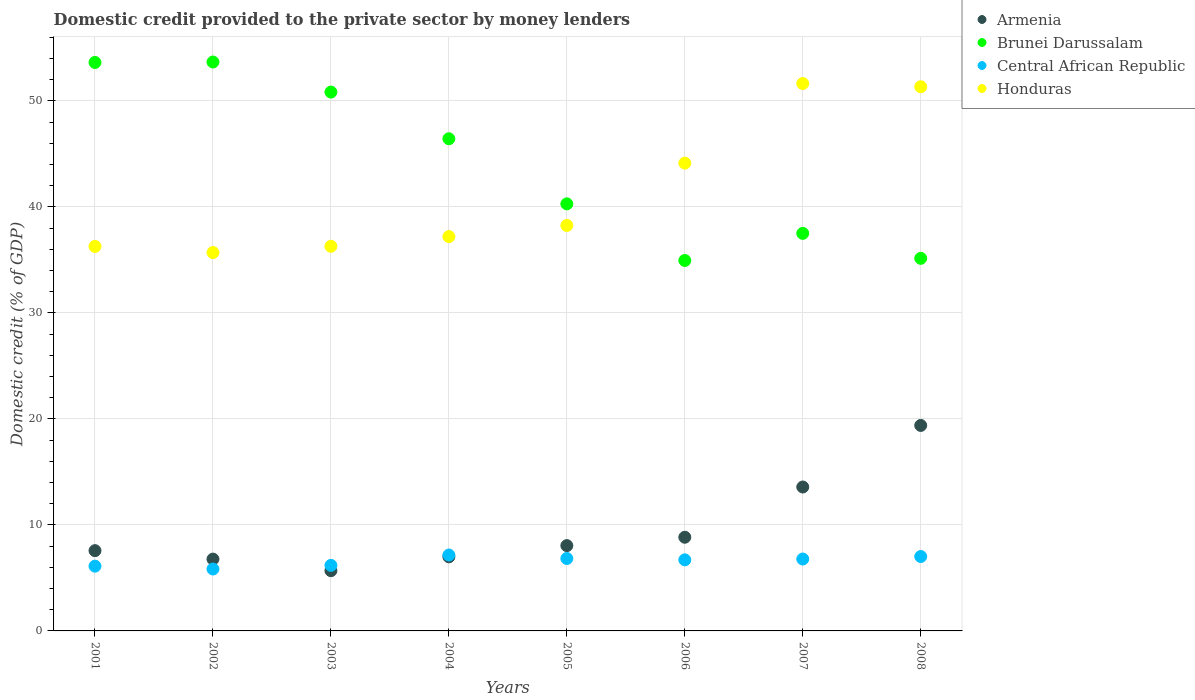What is the domestic credit provided to the private sector by money lenders in Honduras in 2004?
Your answer should be compact. 37.2. Across all years, what is the maximum domestic credit provided to the private sector by money lenders in Brunei Darussalam?
Your answer should be very brief. 53.68. Across all years, what is the minimum domestic credit provided to the private sector by money lenders in Brunei Darussalam?
Provide a short and direct response. 34.95. In which year was the domestic credit provided to the private sector by money lenders in Brunei Darussalam maximum?
Offer a terse response. 2002. In which year was the domestic credit provided to the private sector by money lenders in Armenia minimum?
Your response must be concise. 2003. What is the total domestic credit provided to the private sector by money lenders in Central African Republic in the graph?
Offer a very short reply. 52.64. What is the difference between the domestic credit provided to the private sector by money lenders in Armenia in 2004 and that in 2008?
Offer a terse response. -12.4. What is the difference between the domestic credit provided to the private sector by money lenders in Honduras in 2004 and the domestic credit provided to the private sector by money lenders in Brunei Darussalam in 2002?
Offer a terse response. -16.47. What is the average domestic credit provided to the private sector by money lenders in Central African Republic per year?
Provide a short and direct response. 6.58. In the year 2007, what is the difference between the domestic credit provided to the private sector by money lenders in Central African Republic and domestic credit provided to the private sector by money lenders in Armenia?
Make the answer very short. -6.79. What is the ratio of the domestic credit provided to the private sector by money lenders in Brunei Darussalam in 2001 to that in 2005?
Ensure brevity in your answer.  1.33. Is the difference between the domestic credit provided to the private sector by money lenders in Central African Republic in 2001 and 2005 greater than the difference between the domestic credit provided to the private sector by money lenders in Armenia in 2001 and 2005?
Your answer should be very brief. No. What is the difference between the highest and the second highest domestic credit provided to the private sector by money lenders in Brunei Darussalam?
Offer a very short reply. 0.04. What is the difference between the highest and the lowest domestic credit provided to the private sector by money lenders in Central African Republic?
Your answer should be compact. 1.32. In how many years, is the domestic credit provided to the private sector by money lenders in Armenia greater than the average domestic credit provided to the private sector by money lenders in Armenia taken over all years?
Ensure brevity in your answer.  2. Is it the case that in every year, the sum of the domestic credit provided to the private sector by money lenders in Honduras and domestic credit provided to the private sector by money lenders in Brunei Darussalam  is greater than the domestic credit provided to the private sector by money lenders in Armenia?
Your answer should be very brief. Yes. Is the domestic credit provided to the private sector by money lenders in Armenia strictly greater than the domestic credit provided to the private sector by money lenders in Central African Republic over the years?
Offer a terse response. No. What is the difference between two consecutive major ticks on the Y-axis?
Offer a very short reply. 10. Where does the legend appear in the graph?
Keep it short and to the point. Top right. How are the legend labels stacked?
Provide a succinct answer. Vertical. What is the title of the graph?
Make the answer very short. Domestic credit provided to the private sector by money lenders. What is the label or title of the Y-axis?
Give a very brief answer. Domestic credit (% of GDP). What is the Domestic credit (% of GDP) in Armenia in 2001?
Provide a succinct answer. 7.57. What is the Domestic credit (% of GDP) in Brunei Darussalam in 2001?
Offer a very short reply. 53.63. What is the Domestic credit (% of GDP) of Central African Republic in 2001?
Give a very brief answer. 6.11. What is the Domestic credit (% of GDP) in Honduras in 2001?
Provide a short and direct response. 36.28. What is the Domestic credit (% of GDP) in Armenia in 2002?
Your answer should be very brief. 6.78. What is the Domestic credit (% of GDP) in Brunei Darussalam in 2002?
Provide a short and direct response. 53.68. What is the Domestic credit (% of GDP) of Central African Republic in 2002?
Keep it short and to the point. 5.84. What is the Domestic credit (% of GDP) of Honduras in 2002?
Keep it short and to the point. 35.7. What is the Domestic credit (% of GDP) of Armenia in 2003?
Make the answer very short. 5.68. What is the Domestic credit (% of GDP) in Brunei Darussalam in 2003?
Provide a short and direct response. 50.84. What is the Domestic credit (% of GDP) in Central African Republic in 2003?
Make the answer very short. 6.18. What is the Domestic credit (% of GDP) in Honduras in 2003?
Give a very brief answer. 36.29. What is the Domestic credit (% of GDP) of Armenia in 2004?
Provide a short and direct response. 6.99. What is the Domestic credit (% of GDP) in Brunei Darussalam in 2004?
Give a very brief answer. 46.44. What is the Domestic credit (% of GDP) in Central African Republic in 2004?
Your answer should be compact. 7.16. What is the Domestic credit (% of GDP) of Honduras in 2004?
Your answer should be compact. 37.2. What is the Domestic credit (% of GDP) in Armenia in 2005?
Your answer should be very brief. 8.05. What is the Domestic credit (% of GDP) of Brunei Darussalam in 2005?
Provide a short and direct response. 40.29. What is the Domestic credit (% of GDP) in Central African Republic in 2005?
Keep it short and to the point. 6.83. What is the Domestic credit (% of GDP) in Honduras in 2005?
Make the answer very short. 38.26. What is the Domestic credit (% of GDP) in Armenia in 2006?
Give a very brief answer. 8.84. What is the Domestic credit (% of GDP) in Brunei Darussalam in 2006?
Give a very brief answer. 34.95. What is the Domestic credit (% of GDP) of Central African Republic in 2006?
Provide a short and direct response. 6.71. What is the Domestic credit (% of GDP) of Honduras in 2006?
Provide a succinct answer. 44.14. What is the Domestic credit (% of GDP) in Armenia in 2007?
Your answer should be compact. 13.58. What is the Domestic credit (% of GDP) in Brunei Darussalam in 2007?
Your answer should be compact. 37.51. What is the Domestic credit (% of GDP) of Central African Republic in 2007?
Keep it short and to the point. 6.78. What is the Domestic credit (% of GDP) in Honduras in 2007?
Ensure brevity in your answer.  51.65. What is the Domestic credit (% of GDP) in Armenia in 2008?
Your response must be concise. 19.39. What is the Domestic credit (% of GDP) of Brunei Darussalam in 2008?
Offer a very short reply. 35.15. What is the Domestic credit (% of GDP) of Central African Republic in 2008?
Offer a terse response. 7.02. What is the Domestic credit (% of GDP) of Honduras in 2008?
Your answer should be very brief. 51.34. Across all years, what is the maximum Domestic credit (% of GDP) in Armenia?
Make the answer very short. 19.39. Across all years, what is the maximum Domestic credit (% of GDP) in Brunei Darussalam?
Make the answer very short. 53.68. Across all years, what is the maximum Domestic credit (% of GDP) in Central African Republic?
Your answer should be compact. 7.16. Across all years, what is the maximum Domestic credit (% of GDP) in Honduras?
Keep it short and to the point. 51.65. Across all years, what is the minimum Domestic credit (% of GDP) of Armenia?
Your answer should be compact. 5.68. Across all years, what is the minimum Domestic credit (% of GDP) of Brunei Darussalam?
Provide a succinct answer. 34.95. Across all years, what is the minimum Domestic credit (% of GDP) in Central African Republic?
Your answer should be compact. 5.84. Across all years, what is the minimum Domestic credit (% of GDP) in Honduras?
Provide a short and direct response. 35.7. What is the total Domestic credit (% of GDP) of Armenia in the graph?
Your answer should be compact. 76.87. What is the total Domestic credit (% of GDP) in Brunei Darussalam in the graph?
Offer a very short reply. 352.49. What is the total Domestic credit (% of GDP) in Central African Republic in the graph?
Provide a succinct answer. 52.64. What is the total Domestic credit (% of GDP) of Honduras in the graph?
Offer a terse response. 330.85. What is the difference between the Domestic credit (% of GDP) in Armenia in 2001 and that in 2002?
Offer a terse response. 0.8. What is the difference between the Domestic credit (% of GDP) in Brunei Darussalam in 2001 and that in 2002?
Keep it short and to the point. -0.04. What is the difference between the Domestic credit (% of GDP) in Central African Republic in 2001 and that in 2002?
Ensure brevity in your answer.  0.27. What is the difference between the Domestic credit (% of GDP) in Honduras in 2001 and that in 2002?
Ensure brevity in your answer.  0.58. What is the difference between the Domestic credit (% of GDP) of Armenia in 2001 and that in 2003?
Your answer should be very brief. 1.89. What is the difference between the Domestic credit (% of GDP) of Brunei Darussalam in 2001 and that in 2003?
Your response must be concise. 2.79. What is the difference between the Domestic credit (% of GDP) of Central African Republic in 2001 and that in 2003?
Provide a succinct answer. -0.07. What is the difference between the Domestic credit (% of GDP) of Honduras in 2001 and that in 2003?
Keep it short and to the point. -0.01. What is the difference between the Domestic credit (% of GDP) of Armenia in 2001 and that in 2004?
Your answer should be very brief. 0.58. What is the difference between the Domestic credit (% of GDP) of Brunei Darussalam in 2001 and that in 2004?
Make the answer very short. 7.2. What is the difference between the Domestic credit (% of GDP) in Central African Republic in 2001 and that in 2004?
Make the answer very short. -1.05. What is the difference between the Domestic credit (% of GDP) in Honduras in 2001 and that in 2004?
Provide a succinct answer. -0.93. What is the difference between the Domestic credit (% of GDP) in Armenia in 2001 and that in 2005?
Make the answer very short. -0.47. What is the difference between the Domestic credit (% of GDP) in Brunei Darussalam in 2001 and that in 2005?
Make the answer very short. 13.34. What is the difference between the Domestic credit (% of GDP) of Central African Republic in 2001 and that in 2005?
Give a very brief answer. -0.72. What is the difference between the Domestic credit (% of GDP) in Honduras in 2001 and that in 2005?
Offer a very short reply. -1.98. What is the difference between the Domestic credit (% of GDP) in Armenia in 2001 and that in 2006?
Give a very brief answer. -1.26. What is the difference between the Domestic credit (% of GDP) in Brunei Darussalam in 2001 and that in 2006?
Your answer should be compact. 18.68. What is the difference between the Domestic credit (% of GDP) of Central African Republic in 2001 and that in 2006?
Your answer should be compact. -0.6. What is the difference between the Domestic credit (% of GDP) of Honduras in 2001 and that in 2006?
Your answer should be very brief. -7.86. What is the difference between the Domestic credit (% of GDP) in Armenia in 2001 and that in 2007?
Ensure brevity in your answer.  -6. What is the difference between the Domestic credit (% of GDP) in Brunei Darussalam in 2001 and that in 2007?
Offer a terse response. 16.13. What is the difference between the Domestic credit (% of GDP) of Central African Republic in 2001 and that in 2007?
Give a very brief answer. -0.67. What is the difference between the Domestic credit (% of GDP) in Honduras in 2001 and that in 2007?
Your response must be concise. -15.37. What is the difference between the Domestic credit (% of GDP) in Armenia in 2001 and that in 2008?
Keep it short and to the point. -11.81. What is the difference between the Domestic credit (% of GDP) in Brunei Darussalam in 2001 and that in 2008?
Offer a very short reply. 18.48. What is the difference between the Domestic credit (% of GDP) of Central African Republic in 2001 and that in 2008?
Provide a short and direct response. -0.91. What is the difference between the Domestic credit (% of GDP) in Honduras in 2001 and that in 2008?
Provide a succinct answer. -15.07. What is the difference between the Domestic credit (% of GDP) of Armenia in 2002 and that in 2003?
Keep it short and to the point. 1.09. What is the difference between the Domestic credit (% of GDP) of Brunei Darussalam in 2002 and that in 2003?
Provide a succinct answer. 2.84. What is the difference between the Domestic credit (% of GDP) of Central African Republic in 2002 and that in 2003?
Your answer should be very brief. -0.34. What is the difference between the Domestic credit (% of GDP) in Honduras in 2002 and that in 2003?
Provide a succinct answer. -0.59. What is the difference between the Domestic credit (% of GDP) of Armenia in 2002 and that in 2004?
Your answer should be very brief. -0.21. What is the difference between the Domestic credit (% of GDP) in Brunei Darussalam in 2002 and that in 2004?
Your response must be concise. 7.24. What is the difference between the Domestic credit (% of GDP) of Central African Republic in 2002 and that in 2004?
Your response must be concise. -1.32. What is the difference between the Domestic credit (% of GDP) in Honduras in 2002 and that in 2004?
Your response must be concise. -1.51. What is the difference between the Domestic credit (% of GDP) in Armenia in 2002 and that in 2005?
Provide a short and direct response. -1.27. What is the difference between the Domestic credit (% of GDP) of Brunei Darussalam in 2002 and that in 2005?
Give a very brief answer. 13.38. What is the difference between the Domestic credit (% of GDP) in Central African Republic in 2002 and that in 2005?
Provide a succinct answer. -0.99. What is the difference between the Domestic credit (% of GDP) of Honduras in 2002 and that in 2005?
Give a very brief answer. -2.56. What is the difference between the Domestic credit (% of GDP) in Armenia in 2002 and that in 2006?
Your response must be concise. -2.06. What is the difference between the Domestic credit (% of GDP) of Brunei Darussalam in 2002 and that in 2006?
Ensure brevity in your answer.  18.73. What is the difference between the Domestic credit (% of GDP) in Central African Republic in 2002 and that in 2006?
Your response must be concise. -0.87. What is the difference between the Domestic credit (% of GDP) in Honduras in 2002 and that in 2006?
Your answer should be compact. -8.44. What is the difference between the Domestic credit (% of GDP) in Armenia in 2002 and that in 2007?
Your answer should be compact. -6.8. What is the difference between the Domestic credit (% of GDP) in Brunei Darussalam in 2002 and that in 2007?
Your answer should be very brief. 16.17. What is the difference between the Domestic credit (% of GDP) in Central African Republic in 2002 and that in 2007?
Offer a very short reply. -0.94. What is the difference between the Domestic credit (% of GDP) in Honduras in 2002 and that in 2007?
Keep it short and to the point. -15.95. What is the difference between the Domestic credit (% of GDP) in Armenia in 2002 and that in 2008?
Ensure brevity in your answer.  -12.61. What is the difference between the Domestic credit (% of GDP) in Brunei Darussalam in 2002 and that in 2008?
Your response must be concise. 18.52. What is the difference between the Domestic credit (% of GDP) of Central African Republic in 2002 and that in 2008?
Ensure brevity in your answer.  -1.18. What is the difference between the Domestic credit (% of GDP) of Honduras in 2002 and that in 2008?
Keep it short and to the point. -15.64. What is the difference between the Domestic credit (% of GDP) of Armenia in 2003 and that in 2004?
Offer a terse response. -1.31. What is the difference between the Domestic credit (% of GDP) of Brunei Darussalam in 2003 and that in 2004?
Give a very brief answer. 4.4. What is the difference between the Domestic credit (% of GDP) of Central African Republic in 2003 and that in 2004?
Offer a very short reply. -0.98. What is the difference between the Domestic credit (% of GDP) of Honduras in 2003 and that in 2004?
Ensure brevity in your answer.  -0.91. What is the difference between the Domestic credit (% of GDP) in Armenia in 2003 and that in 2005?
Make the answer very short. -2.37. What is the difference between the Domestic credit (% of GDP) in Brunei Darussalam in 2003 and that in 2005?
Provide a succinct answer. 10.55. What is the difference between the Domestic credit (% of GDP) in Central African Republic in 2003 and that in 2005?
Your answer should be very brief. -0.65. What is the difference between the Domestic credit (% of GDP) in Honduras in 2003 and that in 2005?
Provide a succinct answer. -1.97. What is the difference between the Domestic credit (% of GDP) in Armenia in 2003 and that in 2006?
Your response must be concise. -3.16. What is the difference between the Domestic credit (% of GDP) in Brunei Darussalam in 2003 and that in 2006?
Your answer should be compact. 15.89. What is the difference between the Domestic credit (% of GDP) in Central African Republic in 2003 and that in 2006?
Your answer should be very brief. -0.52. What is the difference between the Domestic credit (% of GDP) in Honduras in 2003 and that in 2006?
Your response must be concise. -7.85. What is the difference between the Domestic credit (% of GDP) in Armenia in 2003 and that in 2007?
Offer a very short reply. -7.9. What is the difference between the Domestic credit (% of GDP) of Brunei Darussalam in 2003 and that in 2007?
Offer a terse response. 13.33. What is the difference between the Domestic credit (% of GDP) of Central African Republic in 2003 and that in 2007?
Your answer should be compact. -0.6. What is the difference between the Domestic credit (% of GDP) of Honduras in 2003 and that in 2007?
Offer a very short reply. -15.36. What is the difference between the Domestic credit (% of GDP) of Armenia in 2003 and that in 2008?
Your answer should be compact. -13.7. What is the difference between the Domestic credit (% of GDP) in Brunei Darussalam in 2003 and that in 2008?
Provide a succinct answer. 15.69. What is the difference between the Domestic credit (% of GDP) of Central African Republic in 2003 and that in 2008?
Give a very brief answer. -0.84. What is the difference between the Domestic credit (% of GDP) of Honduras in 2003 and that in 2008?
Keep it short and to the point. -15.05. What is the difference between the Domestic credit (% of GDP) of Armenia in 2004 and that in 2005?
Your answer should be very brief. -1.06. What is the difference between the Domestic credit (% of GDP) in Brunei Darussalam in 2004 and that in 2005?
Offer a very short reply. 6.14. What is the difference between the Domestic credit (% of GDP) of Central African Republic in 2004 and that in 2005?
Offer a very short reply. 0.33. What is the difference between the Domestic credit (% of GDP) of Honduras in 2004 and that in 2005?
Ensure brevity in your answer.  -1.05. What is the difference between the Domestic credit (% of GDP) of Armenia in 2004 and that in 2006?
Ensure brevity in your answer.  -1.85. What is the difference between the Domestic credit (% of GDP) in Brunei Darussalam in 2004 and that in 2006?
Keep it short and to the point. 11.49. What is the difference between the Domestic credit (% of GDP) in Central African Republic in 2004 and that in 2006?
Your answer should be very brief. 0.45. What is the difference between the Domestic credit (% of GDP) in Honduras in 2004 and that in 2006?
Offer a very short reply. -6.93. What is the difference between the Domestic credit (% of GDP) of Armenia in 2004 and that in 2007?
Keep it short and to the point. -6.59. What is the difference between the Domestic credit (% of GDP) of Brunei Darussalam in 2004 and that in 2007?
Provide a succinct answer. 8.93. What is the difference between the Domestic credit (% of GDP) in Central African Republic in 2004 and that in 2007?
Your answer should be compact. 0.38. What is the difference between the Domestic credit (% of GDP) in Honduras in 2004 and that in 2007?
Your answer should be compact. -14.44. What is the difference between the Domestic credit (% of GDP) of Armenia in 2004 and that in 2008?
Your answer should be compact. -12.4. What is the difference between the Domestic credit (% of GDP) in Brunei Darussalam in 2004 and that in 2008?
Give a very brief answer. 11.28. What is the difference between the Domestic credit (% of GDP) in Central African Republic in 2004 and that in 2008?
Your answer should be very brief. 0.14. What is the difference between the Domestic credit (% of GDP) in Honduras in 2004 and that in 2008?
Ensure brevity in your answer.  -14.14. What is the difference between the Domestic credit (% of GDP) of Armenia in 2005 and that in 2006?
Give a very brief answer. -0.79. What is the difference between the Domestic credit (% of GDP) of Brunei Darussalam in 2005 and that in 2006?
Provide a short and direct response. 5.34. What is the difference between the Domestic credit (% of GDP) in Central African Republic in 2005 and that in 2006?
Offer a terse response. 0.13. What is the difference between the Domestic credit (% of GDP) of Honduras in 2005 and that in 2006?
Offer a terse response. -5.88. What is the difference between the Domestic credit (% of GDP) of Armenia in 2005 and that in 2007?
Keep it short and to the point. -5.53. What is the difference between the Domestic credit (% of GDP) in Brunei Darussalam in 2005 and that in 2007?
Make the answer very short. 2.78. What is the difference between the Domestic credit (% of GDP) of Central African Republic in 2005 and that in 2007?
Provide a succinct answer. 0.05. What is the difference between the Domestic credit (% of GDP) in Honduras in 2005 and that in 2007?
Your answer should be very brief. -13.39. What is the difference between the Domestic credit (% of GDP) of Armenia in 2005 and that in 2008?
Make the answer very short. -11.34. What is the difference between the Domestic credit (% of GDP) in Brunei Darussalam in 2005 and that in 2008?
Your answer should be compact. 5.14. What is the difference between the Domestic credit (% of GDP) of Central African Republic in 2005 and that in 2008?
Give a very brief answer. -0.19. What is the difference between the Domestic credit (% of GDP) of Honduras in 2005 and that in 2008?
Offer a very short reply. -13.09. What is the difference between the Domestic credit (% of GDP) in Armenia in 2006 and that in 2007?
Keep it short and to the point. -4.74. What is the difference between the Domestic credit (% of GDP) of Brunei Darussalam in 2006 and that in 2007?
Offer a very short reply. -2.56. What is the difference between the Domestic credit (% of GDP) of Central African Republic in 2006 and that in 2007?
Give a very brief answer. -0.08. What is the difference between the Domestic credit (% of GDP) of Honduras in 2006 and that in 2007?
Your answer should be compact. -7.51. What is the difference between the Domestic credit (% of GDP) in Armenia in 2006 and that in 2008?
Your response must be concise. -10.55. What is the difference between the Domestic credit (% of GDP) of Brunei Darussalam in 2006 and that in 2008?
Keep it short and to the point. -0.2. What is the difference between the Domestic credit (% of GDP) in Central African Republic in 2006 and that in 2008?
Keep it short and to the point. -0.31. What is the difference between the Domestic credit (% of GDP) of Honduras in 2006 and that in 2008?
Give a very brief answer. -7.21. What is the difference between the Domestic credit (% of GDP) in Armenia in 2007 and that in 2008?
Your response must be concise. -5.81. What is the difference between the Domestic credit (% of GDP) in Brunei Darussalam in 2007 and that in 2008?
Keep it short and to the point. 2.36. What is the difference between the Domestic credit (% of GDP) of Central African Republic in 2007 and that in 2008?
Keep it short and to the point. -0.24. What is the difference between the Domestic credit (% of GDP) in Honduras in 2007 and that in 2008?
Keep it short and to the point. 0.3. What is the difference between the Domestic credit (% of GDP) of Armenia in 2001 and the Domestic credit (% of GDP) of Brunei Darussalam in 2002?
Your response must be concise. -46.1. What is the difference between the Domestic credit (% of GDP) of Armenia in 2001 and the Domestic credit (% of GDP) of Central African Republic in 2002?
Offer a very short reply. 1.73. What is the difference between the Domestic credit (% of GDP) of Armenia in 2001 and the Domestic credit (% of GDP) of Honduras in 2002?
Offer a terse response. -28.13. What is the difference between the Domestic credit (% of GDP) of Brunei Darussalam in 2001 and the Domestic credit (% of GDP) of Central African Republic in 2002?
Your answer should be very brief. 47.79. What is the difference between the Domestic credit (% of GDP) in Brunei Darussalam in 2001 and the Domestic credit (% of GDP) in Honduras in 2002?
Your answer should be very brief. 17.93. What is the difference between the Domestic credit (% of GDP) in Central African Republic in 2001 and the Domestic credit (% of GDP) in Honduras in 2002?
Your answer should be very brief. -29.59. What is the difference between the Domestic credit (% of GDP) in Armenia in 2001 and the Domestic credit (% of GDP) in Brunei Darussalam in 2003?
Keep it short and to the point. -43.27. What is the difference between the Domestic credit (% of GDP) of Armenia in 2001 and the Domestic credit (% of GDP) of Central African Republic in 2003?
Give a very brief answer. 1.39. What is the difference between the Domestic credit (% of GDP) in Armenia in 2001 and the Domestic credit (% of GDP) in Honduras in 2003?
Offer a very short reply. -28.72. What is the difference between the Domestic credit (% of GDP) in Brunei Darussalam in 2001 and the Domestic credit (% of GDP) in Central African Republic in 2003?
Offer a terse response. 47.45. What is the difference between the Domestic credit (% of GDP) in Brunei Darussalam in 2001 and the Domestic credit (% of GDP) in Honduras in 2003?
Keep it short and to the point. 17.34. What is the difference between the Domestic credit (% of GDP) of Central African Republic in 2001 and the Domestic credit (% of GDP) of Honduras in 2003?
Provide a short and direct response. -30.18. What is the difference between the Domestic credit (% of GDP) of Armenia in 2001 and the Domestic credit (% of GDP) of Brunei Darussalam in 2004?
Your response must be concise. -38.86. What is the difference between the Domestic credit (% of GDP) of Armenia in 2001 and the Domestic credit (% of GDP) of Central African Republic in 2004?
Give a very brief answer. 0.41. What is the difference between the Domestic credit (% of GDP) of Armenia in 2001 and the Domestic credit (% of GDP) of Honduras in 2004?
Provide a short and direct response. -29.63. What is the difference between the Domestic credit (% of GDP) in Brunei Darussalam in 2001 and the Domestic credit (% of GDP) in Central African Republic in 2004?
Your answer should be compact. 46.47. What is the difference between the Domestic credit (% of GDP) of Brunei Darussalam in 2001 and the Domestic credit (% of GDP) of Honduras in 2004?
Your response must be concise. 16.43. What is the difference between the Domestic credit (% of GDP) of Central African Republic in 2001 and the Domestic credit (% of GDP) of Honduras in 2004?
Ensure brevity in your answer.  -31.09. What is the difference between the Domestic credit (% of GDP) in Armenia in 2001 and the Domestic credit (% of GDP) in Brunei Darussalam in 2005?
Provide a succinct answer. -32.72. What is the difference between the Domestic credit (% of GDP) of Armenia in 2001 and the Domestic credit (% of GDP) of Central African Republic in 2005?
Keep it short and to the point. 0.74. What is the difference between the Domestic credit (% of GDP) of Armenia in 2001 and the Domestic credit (% of GDP) of Honduras in 2005?
Give a very brief answer. -30.68. What is the difference between the Domestic credit (% of GDP) in Brunei Darussalam in 2001 and the Domestic credit (% of GDP) in Central African Republic in 2005?
Offer a terse response. 46.8. What is the difference between the Domestic credit (% of GDP) of Brunei Darussalam in 2001 and the Domestic credit (% of GDP) of Honduras in 2005?
Your response must be concise. 15.38. What is the difference between the Domestic credit (% of GDP) of Central African Republic in 2001 and the Domestic credit (% of GDP) of Honduras in 2005?
Your answer should be very brief. -32.15. What is the difference between the Domestic credit (% of GDP) of Armenia in 2001 and the Domestic credit (% of GDP) of Brunei Darussalam in 2006?
Ensure brevity in your answer.  -27.38. What is the difference between the Domestic credit (% of GDP) of Armenia in 2001 and the Domestic credit (% of GDP) of Central African Republic in 2006?
Your answer should be compact. 0.87. What is the difference between the Domestic credit (% of GDP) of Armenia in 2001 and the Domestic credit (% of GDP) of Honduras in 2006?
Ensure brevity in your answer.  -36.56. What is the difference between the Domestic credit (% of GDP) of Brunei Darussalam in 2001 and the Domestic credit (% of GDP) of Central African Republic in 2006?
Make the answer very short. 46.93. What is the difference between the Domestic credit (% of GDP) in Brunei Darussalam in 2001 and the Domestic credit (% of GDP) in Honduras in 2006?
Offer a terse response. 9.5. What is the difference between the Domestic credit (% of GDP) in Central African Republic in 2001 and the Domestic credit (% of GDP) in Honduras in 2006?
Offer a terse response. -38.03. What is the difference between the Domestic credit (% of GDP) in Armenia in 2001 and the Domestic credit (% of GDP) in Brunei Darussalam in 2007?
Ensure brevity in your answer.  -29.93. What is the difference between the Domestic credit (% of GDP) of Armenia in 2001 and the Domestic credit (% of GDP) of Central African Republic in 2007?
Give a very brief answer. 0.79. What is the difference between the Domestic credit (% of GDP) of Armenia in 2001 and the Domestic credit (% of GDP) of Honduras in 2007?
Provide a succinct answer. -44.07. What is the difference between the Domestic credit (% of GDP) in Brunei Darussalam in 2001 and the Domestic credit (% of GDP) in Central African Republic in 2007?
Keep it short and to the point. 46.85. What is the difference between the Domestic credit (% of GDP) in Brunei Darussalam in 2001 and the Domestic credit (% of GDP) in Honduras in 2007?
Give a very brief answer. 1.99. What is the difference between the Domestic credit (% of GDP) of Central African Republic in 2001 and the Domestic credit (% of GDP) of Honduras in 2007?
Ensure brevity in your answer.  -45.54. What is the difference between the Domestic credit (% of GDP) of Armenia in 2001 and the Domestic credit (% of GDP) of Brunei Darussalam in 2008?
Your answer should be compact. -27.58. What is the difference between the Domestic credit (% of GDP) in Armenia in 2001 and the Domestic credit (% of GDP) in Central African Republic in 2008?
Your answer should be very brief. 0.55. What is the difference between the Domestic credit (% of GDP) of Armenia in 2001 and the Domestic credit (% of GDP) of Honduras in 2008?
Your answer should be compact. -43.77. What is the difference between the Domestic credit (% of GDP) in Brunei Darussalam in 2001 and the Domestic credit (% of GDP) in Central African Republic in 2008?
Make the answer very short. 46.61. What is the difference between the Domestic credit (% of GDP) of Brunei Darussalam in 2001 and the Domestic credit (% of GDP) of Honduras in 2008?
Ensure brevity in your answer.  2.29. What is the difference between the Domestic credit (% of GDP) in Central African Republic in 2001 and the Domestic credit (% of GDP) in Honduras in 2008?
Ensure brevity in your answer.  -45.23. What is the difference between the Domestic credit (% of GDP) of Armenia in 2002 and the Domestic credit (% of GDP) of Brunei Darussalam in 2003?
Your response must be concise. -44.06. What is the difference between the Domestic credit (% of GDP) in Armenia in 2002 and the Domestic credit (% of GDP) in Central African Republic in 2003?
Ensure brevity in your answer.  0.59. What is the difference between the Domestic credit (% of GDP) in Armenia in 2002 and the Domestic credit (% of GDP) in Honduras in 2003?
Offer a terse response. -29.51. What is the difference between the Domestic credit (% of GDP) in Brunei Darussalam in 2002 and the Domestic credit (% of GDP) in Central African Republic in 2003?
Provide a succinct answer. 47.49. What is the difference between the Domestic credit (% of GDP) in Brunei Darussalam in 2002 and the Domestic credit (% of GDP) in Honduras in 2003?
Make the answer very short. 17.39. What is the difference between the Domestic credit (% of GDP) of Central African Republic in 2002 and the Domestic credit (% of GDP) of Honduras in 2003?
Your answer should be very brief. -30.45. What is the difference between the Domestic credit (% of GDP) of Armenia in 2002 and the Domestic credit (% of GDP) of Brunei Darussalam in 2004?
Give a very brief answer. -39.66. What is the difference between the Domestic credit (% of GDP) of Armenia in 2002 and the Domestic credit (% of GDP) of Central African Republic in 2004?
Provide a short and direct response. -0.38. What is the difference between the Domestic credit (% of GDP) in Armenia in 2002 and the Domestic credit (% of GDP) in Honduras in 2004?
Provide a succinct answer. -30.43. What is the difference between the Domestic credit (% of GDP) of Brunei Darussalam in 2002 and the Domestic credit (% of GDP) of Central African Republic in 2004?
Your answer should be very brief. 46.52. What is the difference between the Domestic credit (% of GDP) in Brunei Darussalam in 2002 and the Domestic credit (% of GDP) in Honduras in 2004?
Provide a short and direct response. 16.47. What is the difference between the Domestic credit (% of GDP) in Central African Republic in 2002 and the Domestic credit (% of GDP) in Honduras in 2004?
Offer a terse response. -31.36. What is the difference between the Domestic credit (% of GDP) of Armenia in 2002 and the Domestic credit (% of GDP) of Brunei Darussalam in 2005?
Keep it short and to the point. -33.52. What is the difference between the Domestic credit (% of GDP) in Armenia in 2002 and the Domestic credit (% of GDP) in Central African Republic in 2005?
Keep it short and to the point. -0.06. What is the difference between the Domestic credit (% of GDP) of Armenia in 2002 and the Domestic credit (% of GDP) of Honduras in 2005?
Keep it short and to the point. -31.48. What is the difference between the Domestic credit (% of GDP) of Brunei Darussalam in 2002 and the Domestic credit (% of GDP) of Central African Republic in 2005?
Provide a succinct answer. 46.84. What is the difference between the Domestic credit (% of GDP) of Brunei Darussalam in 2002 and the Domestic credit (% of GDP) of Honduras in 2005?
Your answer should be very brief. 15.42. What is the difference between the Domestic credit (% of GDP) in Central African Republic in 2002 and the Domestic credit (% of GDP) in Honduras in 2005?
Your response must be concise. -32.42. What is the difference between the Domestic credit (% of GDP) of Armenia in 2002 and the Domestic credit (% of GDP) of Brunei Darussalam in 2006?
Make the answer very short. -28.17. What is the difference between the Domestic credit (% of GDP) of Armenia in 2002 and the Domestic credit (% of GDP) of Central African Republic in 2006?
Provide a succinct answer. 0.07. What is the difference between the Domestic credit (% of GDP) in Armenia in 2002 and the Domestic credit (% of GDP) in Honduras in 2006?
Give a very brief answer. -37.36. What is the difference between the Domestic credit (% of GDP) of Brunei Darussalam in 2002 and the Domestic credit (% of GDP) of Central African Republic in 2006?
Keep it short and to the point. 46.97. What is the difference between the Domestic credit (% of GDP) in Brunei Darussalam in 2002 and the Domestic credit (% of GDP) in Honduras in 2006?
Give a very brief answer. 9.54. What is the difference between the Domestic credit (% of GDP) of Central African Republic in 2002 and the Domestic credit (% of GDP) of Honduras in 2006?
Offer a very short reply. -38.3. What is the difference between the Domestic credit (% of GDP) in Armenia in 2002 and the Domestic credit (% of GDP) in Brunei Darussalam in 2007?
Your answer should be compact. -30.73. What is the difference between the Domestic credit (% of GDP) in Armenia in 2002 and the Domestic credit (% of GDP) in Central African Republic in 2007?
Make the answer very short. -0.01. What is the difference between the Domestic credit (% of GDP) of Armenia in 2002 and the Domestic credit (% of GDP) of Honduras in 2007?
Offer a very short reply. -44.87. What is the difference between the Domestic credit (% of GDP) of Brunei Darussalam in 2002 and the Domestic credit (% of GDP) of Central African Republic in 2007?
Your answer should be compact. 46.89. What is the difference between the Domestic credit (% of GDP) of Brunei Darussalam in 2002 and the Domestic credit (% of GDP) of Honduras in 2007?
Ensure brevity in your answer.  2.03. What is the difference between the Domestic credit (% of GDP) in Central African Republic in 2002 and the Domestic credit (% of GDP) in Honduras in 2007?
Keep it short and to the point. -45.81. What is the difference between the Domestic credit (% of GDP) in Armenia in 2002 and the Domestic credit (% of GDP) in Brunei Darussalam in 2008?
Provide a short and direct response. -28.38. What is the difference between the Domestic credit (% of GDP) of Armenia in 2002 and the Domestic credit (% of GDP) of Central African Republic in 2008?
Ensure brevity in your answer.  -0.24. What is the difference between the Domestic credit (% of GDP) in Armenia in 2002 and the Domestic credit (% of GDP) in Honduras in 2008?
Offer a terse response. -44.57. What is the difference between the Domestic credit (% of GDP) of Brunei Darussalam in 2002 and the Domestic credit (% of GDP) of Central African Republic in 2008?
Give a very brief answer. 46.66. What is the difference between the Domestic credit (% of GDP) of Brunei Darussalam in 2002 and the Domestic credit (% of GDP) of Honduras in 2008?
Give a very brief answer. 2.33. What is the difference between the Domestic credit (% of GDP) in Central African Republic in 2002 and the Domestic credit (% of GDP) in Honduras in 2008?
Make the answer very short. -45.5. What is the difference between the Domestic credit (% of GDP) in Armenia in 2003 and the Domestic credit (% of GDP) in Brunei Darussalam in 2004?
Your answer should be very brief. -40.75. What is the difference between the Domestic credit (% of GDP) in Armenia in 2003 and the Domestic credit (% of GDP) in Central African Republic in 2004?
Provide a succinct answer. -1.48. What is the difference between the Domestic credit (% of GDP) of Armenia in 2003 and the Domestic credit (% of GDP) of Honduras in 2004?
Make the answer very short. -31.52. What is the difference between the Domestic credit (% of GDP) of Brunei Darussalam in 2003 and the Domestic credit (% of GDP) of Central African Republic in 2004?
Give a very brief answer. 43.68. What is the difference between the Domestic credit (% of GDP) of Brunei Darussalam in 2003 and the Domestic credit (% of GDP) of Honduras in 2004?
Offer a terse response. 13.63. What is the difference between the Domestic credit (% of GDP) of Central African Republic in 2003 and the Domestic credit (% of GDP) of Honduras in 2004?
Provide a succinct answer. -31.02. What is the difference between the Domestic credit (% of GDP) in Armenia in 2003 and the Domestic credit (% of GDP) in Brunei Darussalam in 2005?
Give a very brief answer. -34.61. What is the difference between the Domestic credit (% of GDP) in Armenia in 2003 and the Domestic credit (% of GDP) in Central African Republic in 2005?
Give a very brief answer. -1.15. What is the difference between the Domestic credit (% of GDP) in Armenia in 2003 and the Domestic credit (% of GDP) in Honduras in 2005?
Offer a very short reply. -32.57. What is the difference between the Domestic credit (% of GDP) in Brunei Darussalam in 2003 and the Domestic credit (% of GDP) in Central African Republic in 2005?
Your response must be concise. 44.01. What is the difference between the Domestic credit (% of GDP) in Brunei Darussalam in 2003 and the Domestic credit (% of GDP) in Honduras in 2005?
Keep it short and to the point. 12.58. What is the difference between the Domestic credit (% of GDP) of Central African Republic in 2003 and the Domestic credit (% of GDP) of Honduras in 2005?
Provide a short and direct response. -32.07. What is the difference between the Domestic credit (% of GDP) in Armenia in 2003 and the Domestic credit (% of GDP) in Brunei Darussalam in 2006?
Ensure brevity in your answer.  -29.27. What is the difference between the Domestic credit (% of GDP) of Armenia in 2003 and the Domestic credit (% of GDP) of Central African Republic in 2006?
Your answer should be very brief. -1.02. What is the difference between the Domestic credit (% of GDP) of Armenia in 2003 and the Domestic credit (% of GDP) of Honduras in 2006?
Provide a succinct answer. -38.45. What is the difference between the Domestic credit (% of GDP) in Brunei Darussalam in 2003 and the Domestic credit (% of GDP) in Central African Republic in 2006?
Your answer should be compact. 44.13. What is the difference between the Domestic credit (% of GDP) of Brunei Darussalam in 2003 and the Domestic credit (% of GDP) of Honduras in 2006?
Keep it short and to the point. 6.7. What is the difference between the Domestic credit (% of GDP) of Central African Republic in 2003 and the Domestic credit (% of GDP) of Honduras in 2006?
Offer a very short reply. -37.95. What is the difference between the Domestic credit (% of GDP) of Armenia in 2003 and the Domestic credit (% of GDP) of Brunei Darussalam in 2007?
Your answer should be very brief. -31.83. What is the difference between the Domestic credit (% of GDP) in Armenia in 2003 and the Domestic credit (% of GDP) in Central African Republic in 2007?
Your answer should be compact. -1.1. What is the difference between the Domestic credit (% of GDP) in Armenia in 2003 and the Domestic credit (% of GDP) in Honduras in 2007?
Offer a very short reply. -45.96. What is the difference between the Domestic credit (% of GDP) of Brunei Darussalam in 2003 and the Domestic credit (% of GDP) of Central African Republic in 2007?
Make the answer very short. 44.06. What is the difference between the Domestic credit (% of GDP) of Brunei Darussalam in 2003 and the Domestic credit (% of GDP) of Honduras in 2007?
Offer a very short reply. -0.81. What is the difference between the Domestic credit (% of GDP) in Central African Republic in 2003 and the Domestic credit (% of GDP) in Honduras in 2007?
Offer a very short reply. -45.46. What is the difference between the Domestic credit (% of GDP) in Armenia in 2003 and the Domestic credit (% of GDP) in Brunei Darussalam in 2008?
Your response must be concise. -29.47. What is the difference between the Domestic credit (% of GDP) in Armenia in 2003 and the Domestic credit (% of GDP) in Central African Republic in 2008?
Give a very brief answer. -1.34. What is the difference between the Domestic credit (% of GDP) in Armenia in 2003 and the Domestic credit (% of GDP) in Honduras in 2008?
Provide a short and direct response. -45.66. What is the difference between the Domestic credit (% of GDP) of Brunei Darussalam in 2003 and the Domestic credit (% of GDP) of Central African Republic in 2008?
Offer a very short reply. 43.82. What is the difference between the Domestic credit (% of GDP) in Brunei Darussalam in 2003 and the Domestic credit (% of GDP) in Honduras in 2008?
Your response must be concise. -0.5. What is the difference between the Domestic credit (% of GDP) of Central African Republic in 2003 and the Domestic credit (% of GDP) of Honduras in 2008?
Offer a terse response. -45.16. What is the difference between the Domestic credit (% of GDP) of Armenia in 2004 and the Domestic credit (% of GDP) of Brunei Darussalam in 2005?
Offer a very short reply. -33.3. What is the difference between the Domestic credit (% of GDP) in Armenia in 2004 and the Domestic credit (% of GDP) in Central African Republic in 2005?
Your answer should be very brief. 0.16. What is the difference between the Domestic credit (% of GDP) in Armenia in 2004 and the Domestic credit (% of GDP) in Honduras in 2005?
Your answer should be very brief. -31.27. What is the difference between the Domestic credit (% of GDP) in Brunei Darussalam in 2004 and the Domestic credit (% of GDP) in Central African Republic in 2005?
Make the answer very short. 39.6. What is the difference between the Domestic credit (% of GDP) of Brunei Darussalam in 2004 and the Domestic credit (% of GDP) of Honduras in 2005?
Your answer should be compact. 8.18. What is the difference between the Domestic credit (% of GDP) in Central African Republic in 2004 and the Domestic credit (% of GDP) in Honduras in 2005?
Ensure brevity in your answer.  -31.1. What is the difference between the Domestic credit (% of GDP) of Armenia in 2004 and the Domestic credit (% of GDP) of Brunei Darussalam in 2006?
Provide a succinct answer. -27.96. What is the difference between the Domestic credit (% of GDP) of Armenia in 2004 and the Domestic credit (% of GDP) of Central African Republic in 2006?
Your response must be concise. 0.28. What is the difference between the Domestic credit (% of GDP) of Armenia in 2004 and the Domestic credit (% of GDP) of Honduras in 2006?
Make the answer very short. -37.15. What is the difference between the Domestic credit (% of GDP) of Brunei Darussalam in 2004 and the Domestic credit (% of GDP) of Central African Republic in 2006?
Provide a short and direct response. 39.73. What is the difference between the Domestic credit (% of GDP) of Brunei Darussalam in 2004 and the Domestic credit (% of GDP) of Honduras in 2006?
Provide a short and direct response. 2.3. What is the difference between the Domestic credit (% of GDP) in Central African Republic in 2004 and the Domestic credit (% of GDP) in Honduras in 2006?
Provide a succinct answer. -36.98. What is the difference between the Domestic credit (% of GDP) in Armenia in 2004 and the Domestic credit (% of GDP) in Brunei Darussalam in 2007?
Provide a short and direct response. -30.52. What is the difference between the Domestic credit (% of GDP) of Armenia in 2004 and the Domestic credit (% of GDP) of Central African Republic in 2007?
Give a very brief answer. 0.21. What is the difference between the Domestic credit (% of GDP) in Armenia in 2004 and the Domestic credit (% of GDP) in Honduras in 2007?
Offer a terse response. -44.66. What is the difference between the Domestic credit (% of GDP) of Brunei Darussalam in 2004 and the Domestic credit (% of GDP) of Central African Republic in 2007?
Give a very brief answer. 39.65. What is the difference between the Domestic credit (% of GDP) of Brunei Darussalam in 2004 and the Domestic credit (% of GDP) of Honduras in 2007?
Ensure brevity in your answer.  -5.21. What is the difference between the Domestic credit (% of GDP) in Central African Republic in 2004 and the Domestic credit (% of GDP) in Honduras in 2007?
Your answer should be compact. -44.49. What is the difference between the Domestic credit (% of GDP) in Armenia in 2004 and the Domestic credit (% of GDP) in Brunei Darussalam in 2008?
Give a very brief answer. -28.16. What is the difference between the Domestic credit (% of GDP) in Armenia in 2004 and the Domestic credit (% of GDP) in Central African Republic in 2008?
Your response must be concise. -0.03. What is the difference between the Domestic credit (% of GDP) of Armenia in 2004 and the Domestic credit (% of GDP) of Honduras in 2008?
Offer a very short reply. -44.35. What is the difference between the Domestic credit (% of GDP) of Brunei Darussalam in 2004 and the Domestic credit (% of GDP) of Central African Republic in 2008?
Your answer should be compact. 39.42. What is the difference between the Domestic credit (% of GDP) in Brunei Darussalam in 2004 and the Domestic credit (% of GDP) in Honduras in 2008?
Offer a very short reply. -4.91. What is the difference between the Domestic credit (% of GDP) of Central African Republic in 2004 and the Domestic credit (% of GDP) of Honduras in 2008?
Keep it short and to the point. -44.18. What is the difference between the Domestic credit (% of GDP) of Armenia in 2005 and the Domestic credit (% of GDP) of Brunei Darussalam in 2006?
Offer a terse response. -26.9. What is the difference between the Domestic credit (% of GDP) in Armenia in 2005 and the Domestic credit (% of GDP) in Central African Republic in 2006?
Your response must be concise. 1.34. What is the difference between the Domestic credit (% of GDP) in Armenia in 2005 and the Domestic credit (% of GDP) in Honduras in 2006?
Ensure brevity in your answer.  -36.09. What is the difference between the Domestic credit (% of GDP) of Brunei Darussalam in 2005 and the Domestic credit (% of GDP) of Central African Republic in 2006?
Your response must be concise. 33.59. What is the difference between the Domestic credit (% of GDP) of Brunei Darussalam in 2005 and the Domestic credit (% of GDP) of Honduras in 2006?
Your response must be concise. -3.84. What is the difference between the Domestic credit (% of GDP) of Central African Republic in 2005 and the Domestic credit (% of GDP) of Honduras in 2006?
Provide a short and direct response. -37.3. What is the difference between the Domestic credit (% of GDP) of Armenia in 2005 and the Domestic credit (% of GDP) of Brunei Darussalam in 2007?
Make the answer very short. -29.46. What is the difference between the Domestic credit (% of GDP) of Armenia in 2005 and the Domestic credit (% of GDP) of Central African Republic in 2007?
Give a very brief answer. 1.26. What is the difference between the Domestic credit (% of GDP) of Armenia in 2005 and the Domestic credit (% of GDP) of Honduras in 2007?
Your response must be concise. -43.6. What is the difference between the Domestic credit (% of GDP) of Brunei Darussalam in 2005 and the Domestic credit (% of GDP) of Central African Republic in 2007?
Provide a short and direct response. 33.51. What is the difference between the Domestic credit (% of GDP) of Brunei Darussalam in 2005 and the Domestic credit (% of GDP) of Honduras in 2007?
Provide a succinct answer. -11.35. What is the difference between the Domestic credit (% of GDP) of Central African Republic in 2005 and the Domestic credit (% of GDP) of Honduras in 2007?
Make the answer very short. -44.81. What is the difference between the Domestic credit (% of GDP) of Armenia in 2005 and the Domestic credit (% of GDP) of Brunei Darussalam in 2008?
Offer a terse response. -27.1. What is the difference between the Domestic credit (% of GDP) of Armenia in 2005 and the Domestic credit (% of GDP) of Central African Republic in 2008?
Make the answer very short. 1.03. What is the difference between the Domestic credit (% of GDP) in Armenia in 2005 and the Domestic credit (% of GDP) in Honduras in 2008?
Give a very brief answer. -43.29. What is the difference between the Domestic credit (% of GDP) in Brunei Darussalam in 2005 and the Domestic credit (% of GDP) in Central African Republic in 2008?
Make the answer very short. 33.27. What is the difference between the Domestic credit (% of GDP) in Brunei Darussalam in 2005 and the Domestic credit (% of GDP) in Honduras in 2008?
Provide a short and direct response. -11.05. What is the difference between the Domestic credit (% of GDP) in Central African Republic in 2005 and the Domestic credit (% of GDP) in Honduras in 2008?
Provide a short and direct response. -44.51. What is the difference between the Domestic credit (% of GDP) in Armenia in 2006 and the Domestic credit (% of GDP) in Brunei Darussalam in 2007?
Your answer should be compact. -28.67. What is the difference between the Domestic credit (% of GDP) in Armenia in 2006 and the Domestic credit (% of GDP) in Central African Republic in 2007?
Provide a succinct answer. 2.05. What is the difference between the Domestic credit (% of GDP) of Armenia in 2006 and the Domestic credit (% of GDP) of Honduras in 2007?
Your response must be concise. -42.81. What is the difference between the Domestic credit (% of GDP) of Brunei Darussalam in 2006 and the Domestic credit (% of GDP) of Central African Republic in 2007?
Your answer should be very brief. 28.17. What is the difference between the Domestic credit (% of GDP) in Brunei Darussalam in 2006 and the Domestic credit (% of GDP) in Honduras in 2007?
Make the answer very short. -16.7. What is the difference between the Domestic credit (% of GDP) of Central African Republic in 2006 and the Domestic credit (% of GDP) of Honduras in 2007?
Offer a very short reply. -44.94. What is the difference between the Domestic credit (% of GDP) of Armenia in 2006 and the Domestic credit (% of GDP) of Brunei Darussalam in 2008?
Offer a terse response. -26.31. What is the difference between the Domestic credit (% of GDP) in Armenia in 2006 and the Domestic credit (% of GDP) in Central African Republic in 2008?
Provide a succinct answer. 1.82. What is the difference between the Domestic credit (% of GDP) in Armenia in 2006 and the Domestic credit (% of GDP) in Honduras in 2008?
Make the answer very short. -42.51. What is the difference between the Domestic credit (% of GDP) of Brunei Darussalam in 2006 and the Domestic credit (% of GDP) of Central African Republic in 2008?
Ensure brevity in your answer.  27.93. What is the difference between the Domestic credit (% of GDP) in Brunei Darussalam in 2006 and the Domestic credit (% of GDP) in Honduras in 2008?
Provide a short and direct response. -16.39. What is the difference between the Domestic credit (% of GDP) in Central African Republic in 2006 and the Domestic credit (% of GDP) in Honduras in 2008?
Offer a terse response. -44.64. What is the difference between the Domestic credit (% of GDP) of Armenia in 2007 and the Domestic credit (% of GDP) of Brunei Darussalam in 2008?
Ensure brevity in your answer.  -21.57. What is the difference between the Domestic credit (% of GDP) in Armenia in 2007 and the Domestic credit (% of GDP) in Central African Republic in 2008?
Make the answer very short. 6.56. What is the difference between the Domestic credit (% of GDP) of Armenia in 2007 and the Domestic credit (% of GDP) of Honduras in 2008?
Offer a terse response. -37.76. What is the difference between the Domestic credit (% of GDP) in Brunei Darussalam in 2007 and the Domestic credit (% of GDP) in Central African Republic in 2008?
Your response must be concise. 30.49. What is the difference between the Domestic credit (% of GDP) in Brunei Darussalam in 2007 and the Domestic credit (% of GDP) in Honduras in 2008?
Provide a short and direct response. -13.84. What is the difference between the Domestic credit (% of GDP) in Central African Republic in 2007 and the Domestic credit (% of GDP) in Honduras in 2008?
Offer a terse response. -44.56. What is the average Domestic credit (% of GDP) of Armenia per year?
Provide a succinct answer. 9.61. What is the average Domestic credit (% of GDP) of Brunei Darussalam per year?
Give a very brief answer. 44.06. What is the average Domestic credit (% of GDP) of Central African Republic per year?
Ensure brevity in your answer.  6.58. What is the average Domestic credit (% of GDP) of Honduras per year?
Offer a very short reply. 41.36. In the year 2001, what is the difference between the Domestic credit (% of GDP) of Armenia and Domestic credit (% of GDP) of Brunei Darussalam?
Provide a succinct answer. -46.06. In the year 2001, what is the difference between the Domestic credit (% of GDP) of Armenia and Domestic credit (% of GDP) of Central African Republic?
Keep it short and to the point. 1.46. In the year 2001, what is the difference between the Domestic credit (% of GDP) of Armenia and Domestic credit (% of GDP) of Honduras?
Make the answer very short. -28.7. In the year 2001, what is the difference between the Domestic credit (% of GDP) of Brunei Darussalam and Domestic credit (% of GDP) of Central African Republic?
Your response must be concise. 47.52. In the year 2001, what is the difference between the Domestic credit (% of GDP) in Brunei Darussalam and Domestic credit (% of GDP) in Honduras?
Provide a succinct answer. 17.36. In the year 2001, what is the difference between the Domestic credit (% of GDP) in Central African Republic and Domestic credit (% of GDP) in Honduras?
Your answer should be compact. -30.17. In the year 2002, what is the difference between the Domestic credit (% of GDP) in Armenia and Domestic credit (% of GDP) in Brunei Darussalam?
Your answer should be compact. -46.9. In the year 2002, what is the difference between the Domestic credit (% of GDP) of Armenia and Domestic credit (% of GDP) of Central African Republic?
Your response must be concise. 0.94. In the year 2002, what is the difference between the Domestic credit (% of GDP) in Armenia and Domestic credit (% of GDP) in Honduras?
Your response must be concise. -28.92. In the year 2002, what is the difference between the Domestic credit (% of GDP) in Brunei Darussalam and Domestic credit (% of GDP) in Central African Republic?
Ensure brevity in your answer.  47.84. In the year 2002, what is the difference between the Domestic credit (% of GDP) in Brunei Darussalam and Domestic credit (% of GDP) in Honduras?
Ensure brevity in your answer.  17.98. In the year 2002, what is the difference between the Domestic credit (% of GDP) in Central African Republic and Domestic credit (% of GDP) in Honduras?
Provide a short and direct response. -29.86. In the year 2003, what is the difference between the Domestic credit (% of GDP) in Armenia and Domestic credit (% of GDP) in Brunei Darussalam?
Give a very brief answer. -45.16. In the year 2003, what is the difference between the Domestic credit (% of GDP) of Armenia and Domestic credit (% of GDP) of Central African Republic?
Make the answer very short. -0.5. In the year 2003, what is the difference between the Domestic credit (% of GDP) of Armenia and Domestic credit (% of GDP) of Honduras?
Provide a short and direct response. -30.61. In the year 2003, what is the difference between the Domestic credit (% of GDP) of Brunei Darussalam and Domestic credit (% of GDP) of Central African Republic?
Your answer should be compact. 44.66. In the year 2003, what is the difference between the Domestic credit (% of GDP) in Brunei Darussalam and Domestic credit (% of GDP) in Honduras?
Offer a very short reply. 14.55. In the year 2003, what is the difference between the Domestic credit (% of GDP) in Central African Republic and Domestic credit (% of GDP) in Honduras?
Offer a terse response. -30.11. In the year 2004, what is the difference between the Domestic credit (% of GDP) of Armenia and Domestic credit (% of GDP) of Brunei Darussalam?
Your response must be concise. -39.45. In the year 2004, what is the difference between the Domestic credit (% of GDP) in Armenia and Domestic credit (% of GDP) in Central African Republic?
Give a very brief answer. -0.17. In the year 2004, what is the difference between the Domestic credit (% of GDP) in Armenia and Domestic credit (% of GDP) in Honduras?
Make the answer very short. -30.21. In the year 2004, what is the difference between the Domestic credit (% of GDP) of Brunei Darussalam and Domestic credit (% of GDP) of Central African Republic?
Make the answer very short. 39.28. In the year 2004, what is the difference between the Domestic credit (% of GDP) of Brunei Darussalam and Domestic credit (% of GDP) of Honduras?
Give a very brief answer. 9.23. In the year 2004, what is the difference between the Domestic credit (% of GDP) in Central African Republic and Domestic credit (% of GDP) in Honduras?
Your answer should be compact. -30.04. In the year 2005, what is the difference between the Domestic credit (% of GDP) in Armenia and Domestic credit (% of GDP) in Brunei Darussalam?
Ensure brevity in your answer.  -32.24. In the year 2005, what is the difference between the Domestic credit (% of GDP) of Armenia and Domestic credit (% of GDP) of Central African Republic?
Your answer should be compact. 1.22. In the year 2005, what is the difference between the Domestic credit (% of GDP) of Armenia and Domestic credit (% of GDP) of Honduras?
Your response must be concise. -30.21. In the year 2005, what is the difference between the Domestic credit (% of GDP) of Brunei Darussalam and Domestic credit (% of GDP) of Central African Republic?
Offer a terse response. 33.46. In the year 2005, what is the difference between the Domestic credit (% of GDP) of Brunei Darussalam and Domestic credit (% of GDP) of Honduras?
Your answer should be compact. 2.04. In the year 2005, what is the difference between the Domestic credit (% of GDP) of Central African Republic and Domestic credit (% of GDP) of Honduras?
Keep it short and to the point. -31.42. In the year 2006, what is the difference between the Domestic credit (% of GDP) of Armenia and Domestic credit (% of GDP) of Brunei Darussalam?
Provide a short and direct response. -26.11. In the year 2006, what is the difference between the Domestic credit (% of GDP) in Armenia and Domestic credit (% of GDP) in Central African Republic?
Your answer should be compact. 2.13. In the year 2006, what is the difference between the Domestic credit (% of GDP) in Armenia and Domestic credit (% of GDP) in Honduras?
Your response must be concise. -35.3. In the year 2006, what is the difference between the Domestic credit (% of GDP) of Brunei Darussalam and Domestic credit (% of GDP) of Central African Republic?
Keep it short and to the point. 28.24. In the year 2006, what is the difference between the Domestic credit (% of GDP) of Brunei Darussalam and Domestic credit (% of GDP) of Honduras?
Provide a short and direct response. -9.19. In the year 2006, what is the difference between the Domestic credit (% of GDP) of Central African Republic and Domestic credit (% of GDP) of Honduras?
Your answer should be compact. -37.43. In the year 2007, what is the difference between the Domestic credit (% of GDP) of Armenia and Domestic credit (% of GDP) of Brunei Darussalam?
Your answer should be very brief. -23.93. In the year 2007, what is the difference between the Domestic credit (% of GDP) of Armenia and Domestic credit (% of GDP) of Central African Republic?
Your answer should be very brief. 6.79. In the year 2007, what is the difference between the Domestic credit (% of GDP) in Armenia and Domestic credit (% of GDP) in Honduras?
Your response must be concise. -38.07. In the year 2007, what is the difference between the Domestic credit (% of GDP) in Brunei Darussalam and Domestic credit (% of GDP) in Central African Republic?
Offer a terse response. 30.72. In the year 2007, what is the difference between the Domestic credit (% of GDP) of Brunei Darussalam and Domestic credit (% of GDP) of Honduras?
Offer a very short reply. -14.14. In the year 2007, what is the difference between the Domestic credit (% of GDP) in Central African Republic and Domestic credit (% of GDP) in Honduras?
Your answer should be very brief. -44.86. In the year 2008, what is the difference between the Domestic credit (% of GDP) in Armenia and Domestic credit (% of GDP) in Brunei Darussalam?
Ensure brevity in your answer.  -15.77. In the year 2008, what is the difference between the Domestic credit (% of GDP) of Armenia and Domestic credit (% of GDP) of Central African Republic?
Give a very brief answer. 12.37. In the year 2008, what is the difference between the Domestic credit (% of GDP) of Armenia and Domestic credit (% of GDP) of Honduras?
Keep it short and to the point. -31.96. In the year 2008, what is the difference between the Domestic credit (% of GDP) of Brunei Darussalam and Domestic credit (% of GDP) of Central African Republic?
Provide a succinct answer. 28.13. In the year 2008, what is the difference between the Domestic credit (% of GDP) of Brunei Darussalam and Domestic credit (% of GDP) of Honduras?
Keep it short and to the point. -16.19. In the year 2008, what is the difference between the Domestic credit (% of GDP) of Central African Republic and Domestic credit (% of GDP) of Honduras?
Your answer should be very brief. -44.32. What is the ratio of the Domestic credit (% of GDP) of Armenia in 2001 to that in 2002?
Your answer should be very brief. 1.12. What is the ratio of the Domestic credit (% of GDP) of Central African Republic in 2001 to that in 2002?
Your response must be concise. 1.05. What is the ratio of the Domestic credit (% of GDP) of Honduras in 2001 to that in 2002?
Your answer should be compact. 1.02. What is the ratio of the Domestic credit (% of GDP) of Armenia in 2001 to that in 2003?
Make the answer very short. 1.33. What is the ratio of the Domestic credit (% of GDP) of Brunei Darussalam in 2001 to that in 2003?
Offer a very short reply. 1.05. What is the ratio of the Domestic credit (% of GDP) in Brunei Darussalam in 2001 to that in 2004?
Make the answer very short. 1.16. What is the ratio of the Domestic credit (% of GDP) of Central African Republic in 2001 to that in 2004?
Keep it short and to the point. 0.85. What is the ratio of the Domestic credit (% of GDP) in Honduras in 2001 to that in 2004?
Provide a short and direct response. 0.98. What is the ratio of the Domestic credit (% of GDP) in Armenia in 2001 to that in 2005?
Make the answer very short. 0.94. What is the ratio of the Domestic credit (% of GDP) in Brunei Darussalam in 2001 to that in 2005?
Give a very brief answer. 1.33. What is the ratio of the Domestic credit (% of GDP) in Central African Republic in 2001 to that in 2005?
Offer a terse response. 0.89. What is the ratio of the Domestic credit (% of GDP) of Honduras in 2001 to that in 2005?
Your response must be concise. 0.95. What is the ratio of the Domestic credit (% of GDP) of Armenia in 2001 to that in 2006?
Offer a terse response. 0.86. What is the ratio of the Domestic credit (% of GDP) in Brunei Darussalam in 2001 to that in 2006?
Your answer should be very brief. 1.53. What is the ratio of the Domestic credit (% of GDP) of Central African Republic in 2001 to that in 2006?
Give a very brief answer. 0.91. What is the ratio of the Domestic credit (% of GDP) of Honduras in 2001 to that in 2006?
Make the answer very short. 0.82. What is the ratio of the Domestic credit (% of GDP) in Armenia in 2001 to that in 2007?
Ensure brevity in your answer.  0.56. What is the ratio of the Domestic credit (% of GDP) in Brunei Darussalam in 2001 to that in 2007?
Keep it short and to the point. 1.43. What is the ratio of the Domestic credit (% of GDP) of Central African Republic in 2001 to that in 2007?
Keep it short and to the point. 0.9. What is the ratio of the Domestic credit (% of GDP) of Honduras in 2001 to that in 2007?
Offer a very short reply. 0.7. What is the ratio of the Domestic credit (% of GDP) in Armenia in 2001 to that in 2008?
Your answer should be compact. 0.39. What is the ratio of the Domestic credit (% of GDP) of Brunei Darussalam in 2001 to that in 2008?
Your answer should be very brief. 1.53. What is the ratio of the Domestic credit (% of GDP) of Central African Republic in 2001 to that in 2008?
Make the answer very short. 0.87. What is the ratio of the Domestic credit (% of GDP) of Honduras in 2001 to that in 2008?
Provide a short and direct response. 0.71. What is the ratio of the Domestic credit (% of GDP) in Armenia in 2002 to that in 2003?
Provide a short and direct response. 1.19. What is the ratio of the Domestic credit (% of GDP) of Brunei Darussalam in 2002 to that in 2003?
Make the answer very short. 1.06. What is the ratio of the Domestic credit (% of GDP) in Central African Republic in 2002 to that in 2003?
Give a very brief answer. 0.94. What is the ratio of the Domestic credit (% of GDP) of Honduras in 2002 to that in 2003?
Give a very brief answer. 0.98. What is the ratio of the Domestic credit (% of GDP) of Armenia in 2002 to that in 2004?
Give a very brief answer. 0.97. What is the ratio of the Domestic credit (% of GDP) in Brunei Darussalam in 2002 to that in 2004?
Keep it short and to the point. 1.16. What is the ratio of the Domestic credit (% of GDP) of Central African Republic in 2002 to that in 2004?
Offer a very short reply. 0.82. What is the ratio of the Domestic credit (% of GDP) in Honduras in 2002 to that in 2004?
Offer a very short reply. 0.96. What is the ratio of the Domestic credit (% of GDP) of Armenia in 2002 to that in 2005?
Provide a succinct answer. 0.84. What is the ratio of the Domestic credit (% of GDP) of Brunei Darussalam in 2002 to that in 2005?
Ensure brevity in your answer.  1.33. What is the ratio of the Domestic credit (% of GDP) of Central African Republic in 2002 to that in 2005?
Offer a very short reply. 0.85. What is the ratio of the Domestic credit (% of GDP) of Honduras in 2002 to that in 2005?
Give a very brief answer. 0.93. What is the ratio of the Domestic credit (% of GDP) of Armenia in 2002 to that in 2006?
Provide a short and direct response. 0.77. What is the ratio of the Domestic credit (% of GDP) of Brunei Darussalam in 2002 to that in 2006?
Make the answer very short. 1.54. What is the ratio of the Domestic credit (% of GDP) of Central African Republic in 2002 to that in 2006?
Keep it short and to the point. 0.87. What is the ratio of the Domestic credit (% of GDP) of Honduras in 2002 to that in 2006?
Your answer should be very brief. 0.81. What is the ratio of the Domestic credit (% of GDP) in Armenia in 2002 to that in 2007?
Provide a short and direct response. 0.5. What is the ratio of the Domestic credit (% of GDP) of Brunei Darussalam in 2002 to that in 2007?
Make the answer very short. 1.43. What is the ratio of the Domestic credit (% of GDP) of Central African Republic in 2002 to that in 2007?
Make the answer very short. 0.86. What is the ratio of the Domestic credit (% of GDP) in Honduras in 2002 to that in 2007?
Give a very brief answer. 0.69. What is the ratio of the Domestic credit (% of GDP) in Armenia in 2002 to that in 2008?
Provide a short and direct response. 0.35. What is the ratio of the Domestic credit (% of GDP) of Brunei Darussalam in 2002 to that in 2008?
Provide a succinct answer. 1.53. What is the ratio of the Domestic credit (% of GDP) in Central African Republic in 2002 to that in 2008?
Offer a terse response. 0.83. What is the ratio of the Domestic credit (% of GDP) in Honduras in 2002 to that in 2008?
Your answer should be very brief. 0.7. What is the ratio of the Domestic credit (% of GDP) in Armenia in 2003 to that in 2004?
Make the answer very short. 0.81. What is the ratio of the Domestic credit (% of GDP) in Brunei Darussalam in 2003 to that in 2004?
Offer a very short reply. 1.09. What is the ratio of the Domestic credit (% of GDP) in Central African Republic in 2003 to that in 2004?
Provide a succinct answer. 0.86. What is the ratio of the Domestic credit (% of GDP) in Honduras in 2003 to that in 2004?
Provide a short and direct response. 0.98. What is the ratio of the Domestic credit (% of GDP) in Armenia in 2003 to that in 2005?
Provide a short and direct response. 0.71. What is the ratio of the Domestic credit (% of GDP) of Brunei Darussalam in 2003 to that in 2005?
Provide a succinct answer. 1.26. What is the ratio of the Domestic credit (% of GDP) of Central African Republic in 2003 to that in 2005?
Your response must be concise. 0.91. What is the ratio of the Domestic credit (% of GDP) of Honduras in 2003 to that in 2005?
Provide a short and direct response. 0.95. What is the ratio of the Domestic credit (% of GDP) in Armenia in 2003 to that in 2006?
Your response must be concise. 0.64. What is the ratio of the Domestic credit (% of GDP) in Brunei Darussalam in 2003 to that in 2006?
Provide a short and direct response. 1.45. What is the ratio of the Domestic credit (% of GDP) in Central African Republic in 2003 to that in 2006?
Keep it short and to the point. 0.92. What is the ratio of the Domestic credit (% of GDP) of Honduras in 2003 to that in 2006?
Your answer should be very brief. 0.82. What is the ratio of the Domestic credit (% of GDP) in Armenia in 2003 to that in 2007?
Give a very brief answer. 0.42. What is the ratio of the Domestic credit (% of GDP) in Brunei Darussalam in 2003 to that in 2007?
Keep it short and to the point. 1.36. What is the ratio of the Domestic credit (% of GDP) of Central African Republic in 2003 to that in 2007?
Provide a succinct answer. 0.91. What is the ratio of the Domestic credit (% of GDP) in Honduras in 2003 to that in 2007?
Make the answer very short. 0.7. What is the ratio of the Domestic credit (% of GDP) in Armenia in 2003 to that in 2008?
Provide a succinct answer. 0.29. What is the ratio of the Domestic credit (% of GDP) in Brunei Darussalam in 2003 to that in 2008?
Keep it short and to the point. 1.45. What is the ratio of the Domestic credit (% of GDP) of Central African Republic in 2003 to that in 2008?
Provide a short and direct response. 0.88. What is the ratio of the Domestic credit (% of GDP) of Honduras in 2003 to that in 2008?
Offer a terse response. 0.71. What is the ratio of the Domestic credit (% of GDP) in Armenia in 2004 to that in 2005?
Ensure brevity in your answer.  0.87. What is the ratio of the Domestic credit (% of GDP) of Brunei Darussalam in 2004 to that in 2005?
Ensure brevity in your answer.  1.15. What is the ratio of the Domestic credit (% of GDP) in Central African Republic in 2004 to that in 2005?
Your response must be concise. 1.05. What is the ratio of the Domestic credit (% of GDP) in Honduras in 2004 to that in 2005?
Ensure brevity in your answer.  0.97. What is the ratio of the Domestic credit (% of GDP) in Armenia in 2004 to that in 2006?
Offer a terse response. 0.79. What is the ratio of the Domestic credit (% of GDP) in Brunei Darussalam in 2004 to that in 2006?
Offer a very short reply. 1.33. What is the ratio of the Domestic credit (% of GDP) of Central African Republic in 2004 to that in 2006?
Keep it short and to the point. 1.07. What is the ratio of the Domestic credit (% of GDP) of Honduras in 2004 to that in 2006?
Provide a short and direct response. 0.84. What is the ratio of the Domestic credit (% of GDP) of Armenia in 2004 to that in 2007?
Keep it short and to the point. 0.51. What is the ratio of the Domestic credit (% of GDP) of Brunei Darussalam in 2004 to that in 2007?
Ensure brevity in your answer.  1.24. What is the ratio of the Domestic credit (% of GDP) in Central African Republic in 2004 to that in 2007?
Keep it short and to the point. 1.06. What is the ratio of the Domestic credit (% of GDP) of Honduras in 2004 to that in 2007?
Offer a terse response. 0.72. What is the ratio of the Domestic credit (% of GDP) in Armenia in 2004 to that in 2008?
Make the answer very short. 0.36. What is the ratio of the Domestic credit (% of GDP) in Brunei Darussalam in 2004 to that in 2008?
Offer a terse response. 1.32. What is the ratio of the Domestic credit (% of GDP) in Honduras in 2004 to that in 2008?
Offer a very short reply. 0.72. What is the ratio of the Domestic credit (% of GDP) of Armenia in 2005 to that in 2006?
Offer a terse response. 0.91. What is the ratio of the Domestic credit (% of GDP) in Brunei Darussalam in 2005 to that in 2006?
Your answer should be compact. 1.15. What is the ratio of the Domestic credit (% of GDP) of Central African Republic in 2005 to that in 2006?
Your response must be concise. 1.02. What is the ratio of the Domestic credit (% of GDP) of Honduras in 2005 to that in 2006?
Your answer should be compact. 0.87. What is the ratio of the Domestic credit (% of GDP) in Armenia in 2005 to that in 2007?
Your response must be concise. 0.59. What is the ratio of the Domestic credit (% of GDP) in Brunei Darussalam in 2005 to that in 2007?
Make the answer very short. 1.07. What is the ratio of the Domestic credit (% of GDP) of Central African Republic in 2005 to that in 2007?
Offer a very short reply. 1.01. What is the ratio of the Domestic credit (% of GDP) in Honduras in 2005 to that in 2007?
Offer a terse response. 0.74. What is the ratio of the Domestic credit (% of GDP) in Armenia in 2005 to that in 2008?
Give a very brief answer. 0.42. What is the ratio of the Domestic credit (% of GDP) of Brunei Darussalam in 2005 to that in 2008?
Your answer should be compact. 1.15. What is the ratio of the Domestic credit (% of GDP) in Central African Republic in 2005 to that in 2008?
Offer a very short reply. 0.97. What is the ratio of the Domestic credit (% of GDP) in Honduras in 2005 to that in 2008?
Provide a short and direct response. 0.75. What is the ratio of the Domestic credit (% of GDP) of Armenia in 2006 to that in 2007?
Make the answer very short. 0.65. What is the ratio of the Domestic credit (% of GDP) in Brunei Darussalam in 2006 to that in 2007?
Offer a terse response. 0.93. What is the ratio of the Domestic credit (% of GDP) of Honduras in 2006 to that in 2007?
Make the answer very short. 0.85. What is the ratio of the Domestic credit (% of GDP) in Armenia in 2006 to that in 2008?
Keep it short and to the point. 0.46. What is the ratio of the Domestic credit (% of GDP) of Central African Republic in 2006 to that in 2008?
Offer a very short reply. 0.96. What is the ratio of the Domestic credit (% of GDP) of Honduras in 2006 to that in 2008?
Ensure brevity in your answer.  0.86. What is the ratio of the Domestic credit (% of GDP) of Armenia in 2007 to that in 2008?
Provide a succinct answer. 0.7. What is the ratio of the Domestic credit (% of GDP) of Brunei Darussalam in 2007 to that in 2008?
Provide a succinct answer. 1.07. What is the ratio of the Domestic credit (% of GDP) in Central African Republic in 2007 to that in 2008?
Your answer should be very brief. 0.97. What is the ratio of the Domestic credit (% of GDP) in Honduras in 2007 to that in 2008?
Offer a terse response. 1.01. What is the difference between the highest and the second highest Domestic credit (% of GDP) of Armenia?
Make the answer very short. 5.81. What is the difference between the highest and the second highest Domestic credit (% of GDP) of Brunei Darussalam?
Offer a very short reply. 0.04. What is the difference between the highest and the second highest Domestic credit (% of GDP) in Central African Republic?
Your response must be concise. 0.14. What is the difference between the highest and the second highest Domestic credit (% of GDP) in Honduras?
Offer a terse response. 0.3. What is the difference between the highest and the lowest Domestic credit (% of GDP) of Armenia?
Give a very brief answer. 13.7. What is the difference between the highest and the lowest Domestic credit (% of GDP) of Brunei Darussalam?
Offer a very short reply. 18.73. What is the difference between the highest and the lowest Domestic credit (% of GDP) in Central African Republic?
Your response must be concise. 1.32. What is the difference between the highest and the lowest Domestic credit (% of GDP) of Honduras?
Your response must be concise. 15.95. 